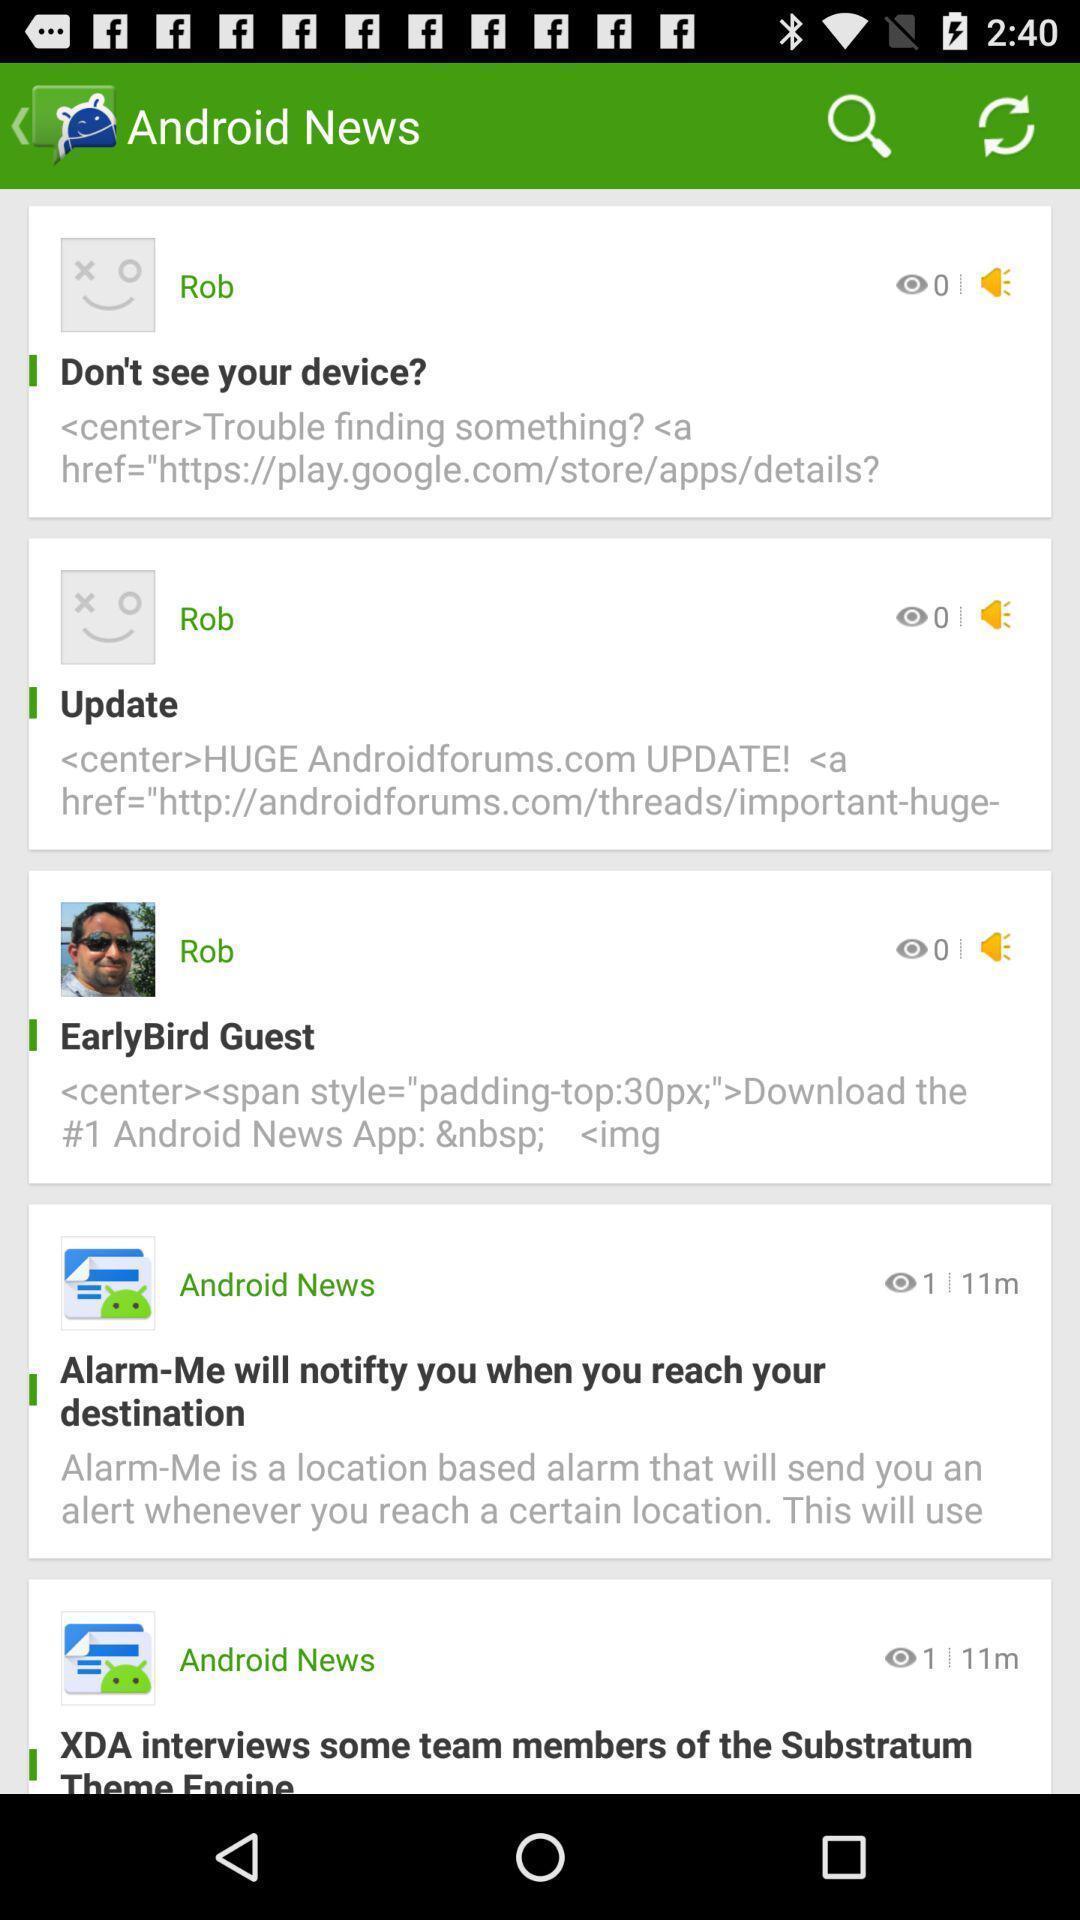Give me a summary of this screen capture. Page displaying various news feeds. 